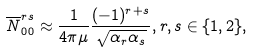<formula> <loc_0><loc_0><loc_500><loc_500>\overline { N } _ { 0 0 } ^ { r s } \approx \frac { 1 } { 4 \pi \mu } \frac { ( - 1 ) ^ { r + s } } { \sqrt { \alpha _ { r } \alpha _ { s } } } , r , s \in \{ 1 , 2 \} ,</formula> 